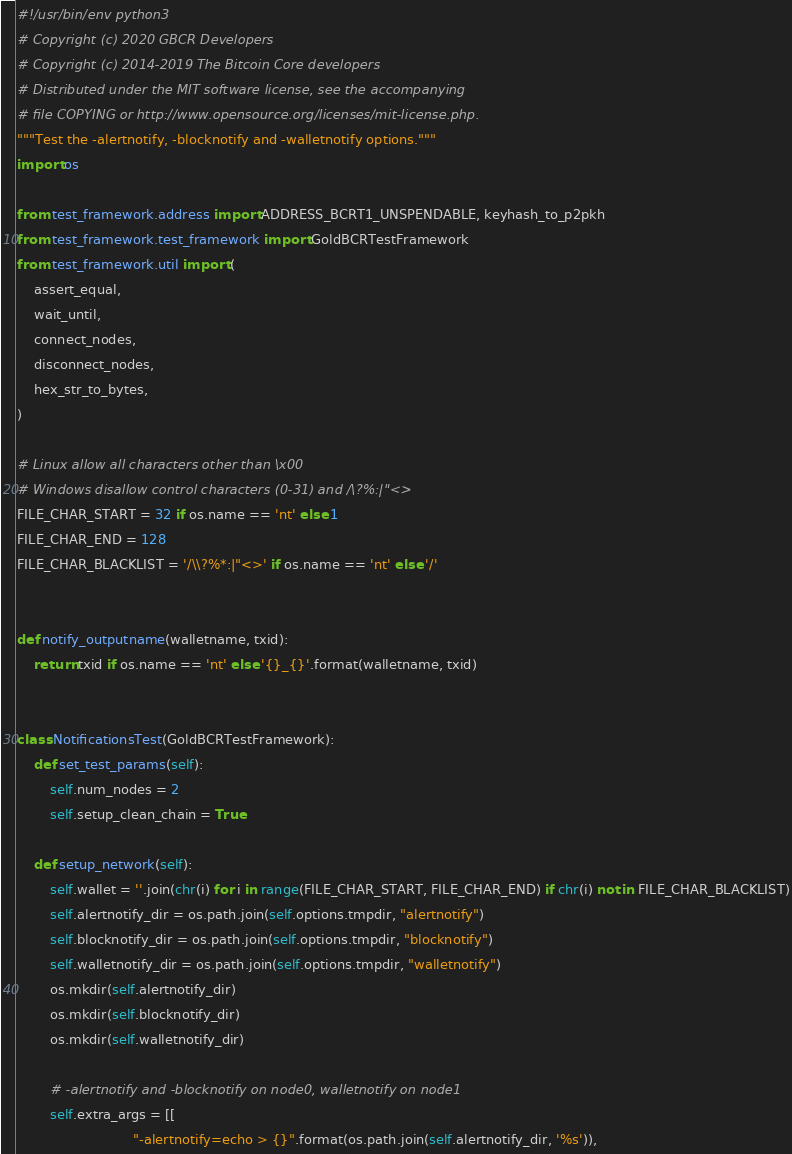Convert code to text. <code><loc_0><loc_0><loc_500><loc_500><_Python_>#!/usr/bin/env python3
# Copyright (c) 2020 GBCR Developers
# Copyright (c) 2014-2019 The Bitcoin Core developers
# Distributed under the MIT software license, see the accompanying
# file COPYING or http://www.opensource.org/licenses/mit-license.php.
"""Test the -alertnotify, -blocknotify and -walletnotify options."""
import os

from test_framework.address import ADDRESS_BCRT1_UNSPENDABLE, keyhash_to_p2pkh
from test_framework.test_framework import GoldBCRTestFramework
from test_framework.util import (
    assert_equal,
    wait_until,
    connect_nodes,
    disconnect_nodes,
    hex_str_to_bytes,
)

# Linux allow all characters other than \x00
# Windows disallow control characters (0-31) and /\?%:|"<>
FILE_CHAR_START = 32 if os.name == 'nt' else 1
FILE_CHAR_END = 128
FILE_CHAR_BLACKLIST = '/\\?%*:|"<>' if os.name == 'nt' else '/'


def notify_outputname(walletname, txid):
    return txid if os.name == 'nt' else '{}_{}'.format(walletname, txid)


class NotificationsTest(GoldBCRTestFramework):
    def set_test_params(self):
        self.num_nodes = 2
        self.setup_clean_chain = True

    def setup_network(self):
        self.wallet = ''.join(chr(i) for i in range(FILE_CHAR_START, FILE_CHAR_END) if chr(i) not in FILE_CHAR_BLACKLIST)
        self.alertnotify_dir = os.path.join(self.options.tmpdir, "alertnotify")
        self.blocknotify_dir = os.path.join(self.options.tmpdir, "blocknotify")
        self.walletnotify_dir = os.path.join(self.options.tmpdir, "walletnotify")
        os.mkdir(self.alertnotify_dir)
        os.mkdir(self.blocknotify_dir)
        os.mkdir(self.walletnotify_dir)

        # -alertnotify and -blocknotify on node0, walletnotify on node1
        self.extra_args = [[
                            "-alertnotify=echo > {}".format(os.path.join(self.alertnotify_dir, '%s')),</code> 